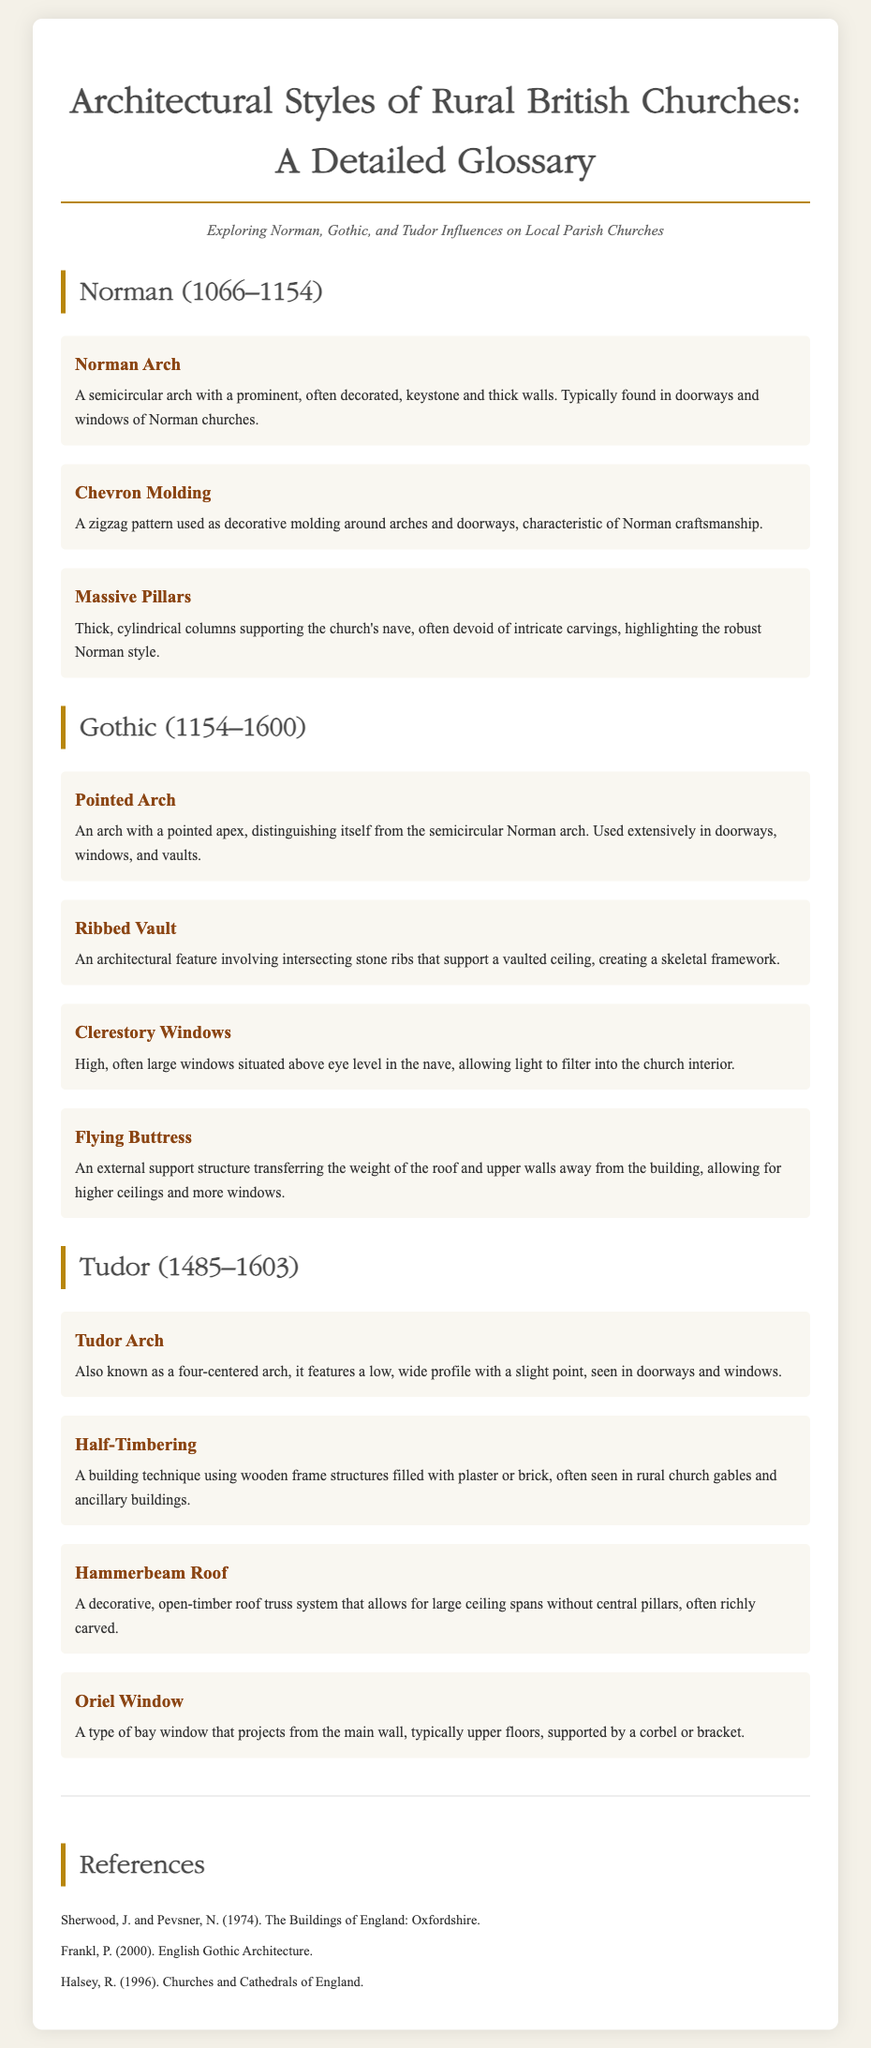What is the title of the document? The title is prominently displayed at the top of the document, stating the overall subject matter.
Answer: Architectural Styles of Rural British Churches: A Detailed Glossary What are the three main architectural styles discussed? The document explicitly lists these styles in the subtitle and headings of the sections.
Answer: Norman, Gothic, Tudor What architectural feature is characterized by a zigzag pattern? This is found in a specific glossary item description within the Norman section, detailing a decorative element.
Answer: Chevron Molding Which period is associated with the use of the Pointed Arch? The dates mentioned in the Gothic section indicate when this architectural feature was prevalent.
Answer: 1154–1600 What is the definition of a Hammerbeam Roof? This term is explained in the Tudor section, describing a specific roofing system seen in churches.
Answer: A decorative, open-timber roof truss system What type of window projects from the main wall and is supported by a corbel or bracket? The Oriel Window is defined in the Tudor section, which describes its structural characteristics.
Answer: Oriel Window How many references are listed at the end of the document? The number of distinct sources cited in the references section provides information on further reading.
Answer: Three 